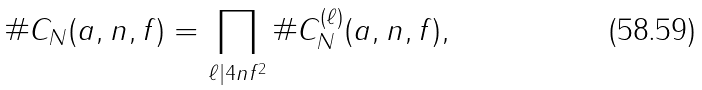Convert formula to latex. <formula><loc_0><loc_0><loc_500><loc_500>\# C _ { N } ( a , n , f ) = \prod _ { \ell | 4 n f ^ { 2 } } \# C _ { N } ^ { ( \ell ) } ( a , n , f ) ,</formula> 